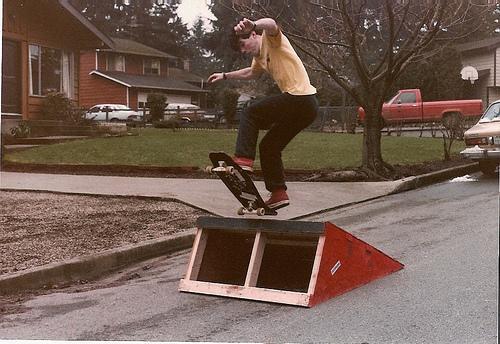How many skateboards are there?
Give a very brief answer. 1. 